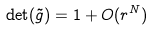<formula> <loc_0><loc_0><loc_500><loc_500>\det ( \tilde { g } ) = 1 + O ( r ^ { N } )</formula> 